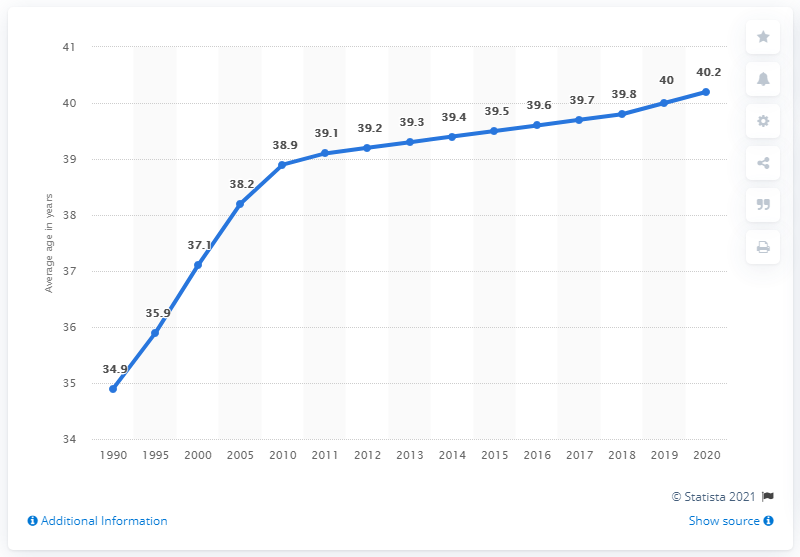What does the increasing trend in the average age from 1990 to 2020 in this graph suggest about Russian society? The upward trend in the average age from 34.9 years in 1990 to 40.2 years in 2020 suggests a significant aging of the Russian population. This can be indicative of lower birth rates and possibly improved healthcare and life expectancy, reflecting broader socioeconomic shifts and challenges like an aging workforce. 